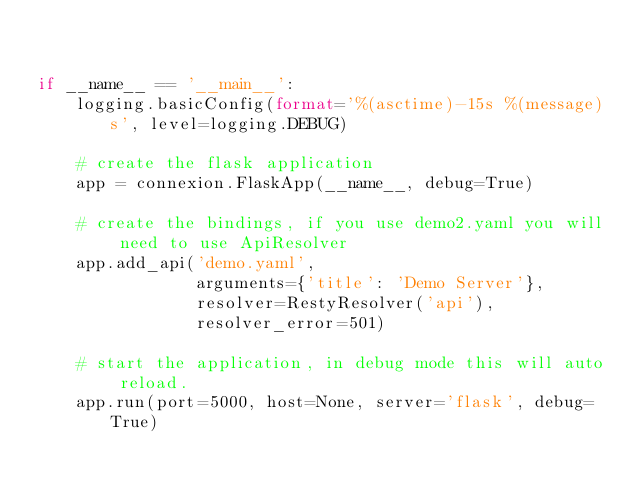<code> <loc_0><loc_0><loc_500><loc_500><_Python_>

if __name__ == '__main__':
    logging.basicConfig(format='%(asctime)-15s %(message)s', level=logging.DEBUG)

    # create the flask application
    app = connexion.FlaskApp(__name__, debug=True)

    # create the bindings, if you use demo2.yaml you will need to use ApiResolver
    app.add_api('demo.yaml',
                arguments={'title': 'Demo Server'},
                resolver=RestyResolver('api'),
                resolver_error=501)

    # start the application, in debug mode this will auto reload.
    app.run(port=5000, host=None, server='flask', debug=True)
</code> 